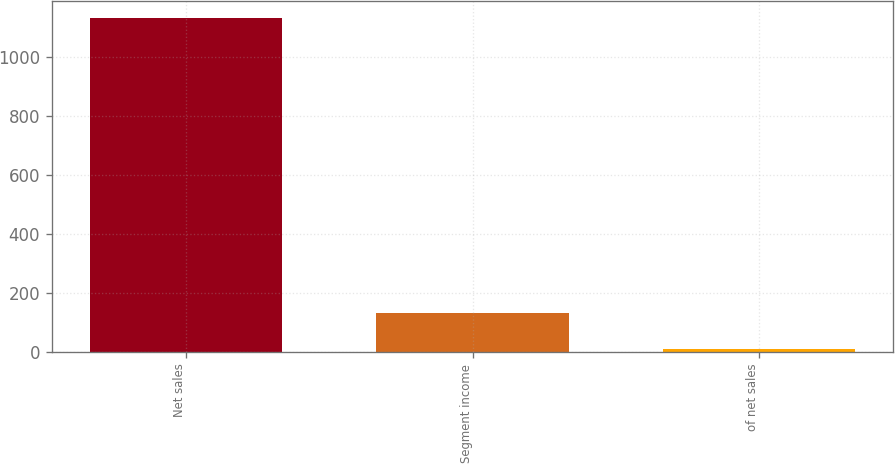Convert chart to OTSL. <chart><loc_0><loc_0><loc_500><loc_500><bar_chart><fcel>Net sales<fcel>Segment income<fcel>of net sales<nl><fcel>1131.6<fcel>132.3<fcel>11.7<nl></chart> 